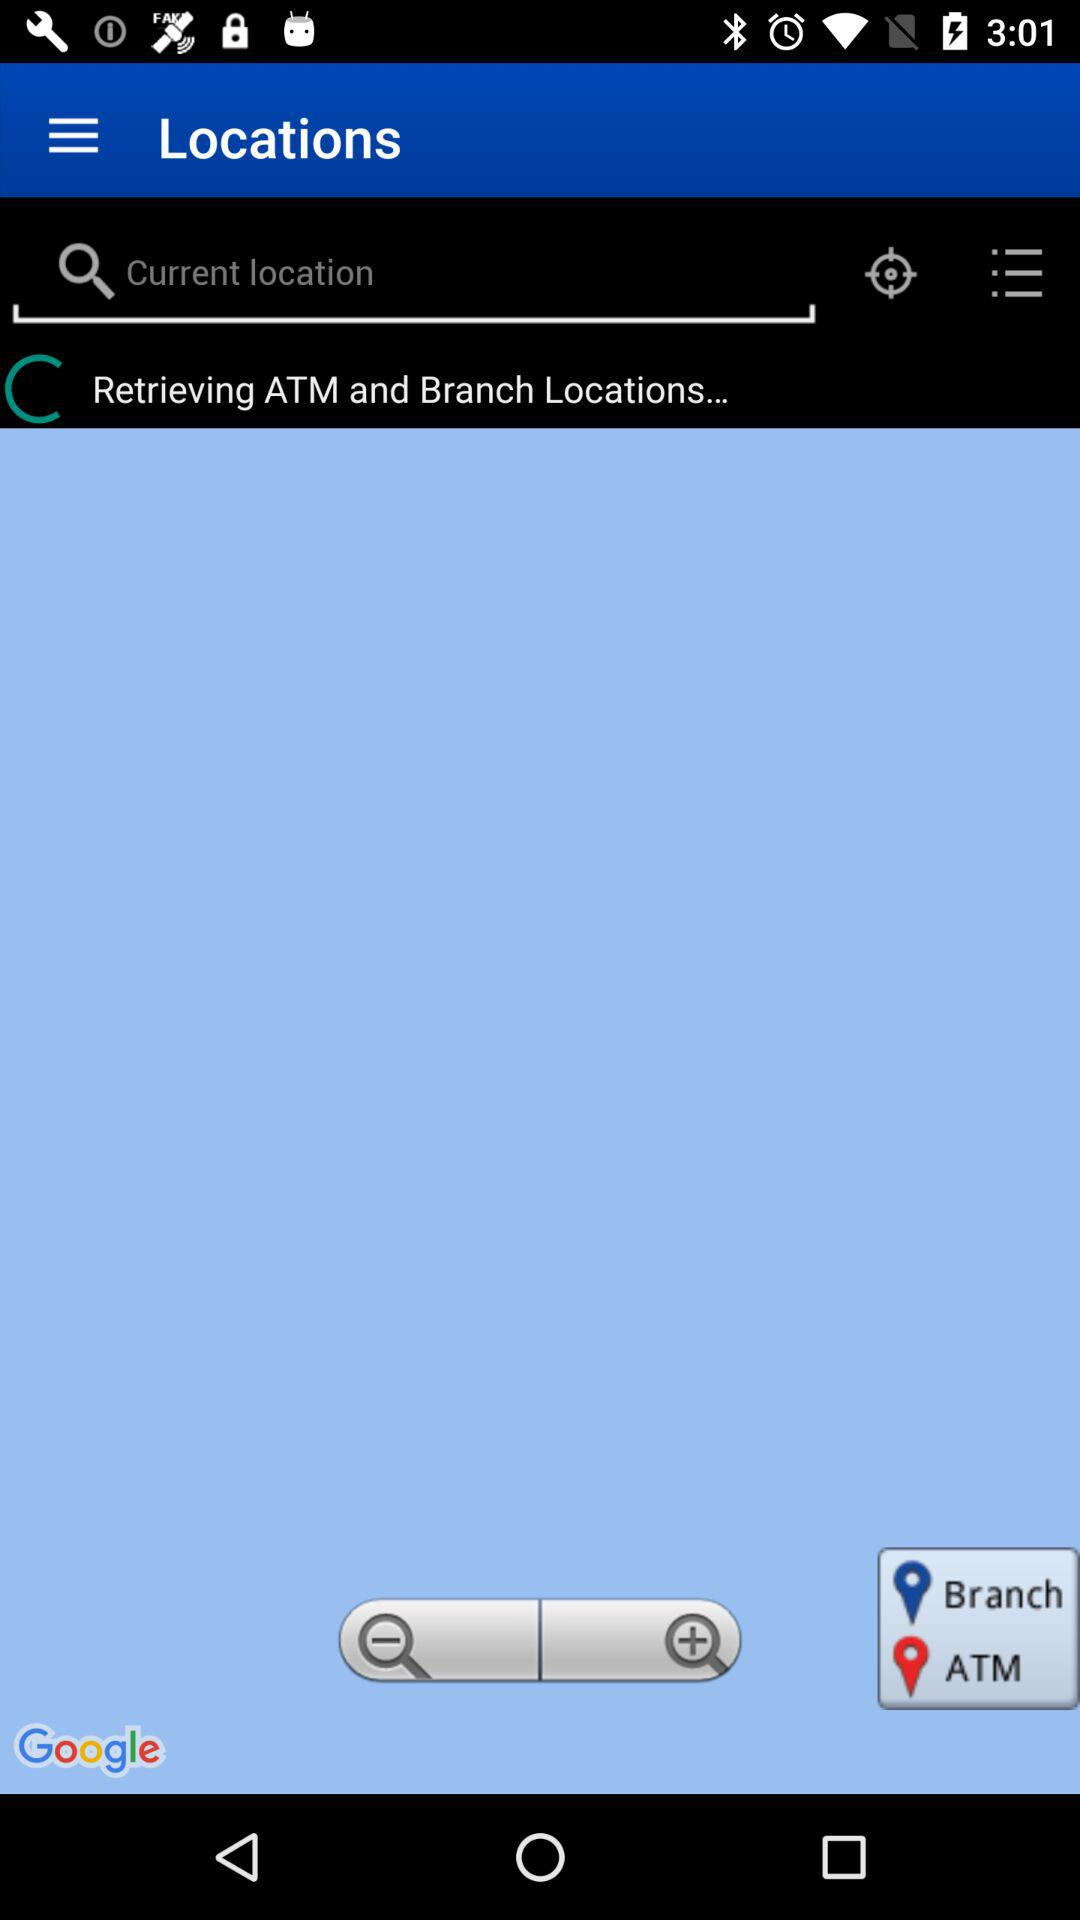What location is being retrieved? The location that is being retrieved is ATM and Branch. 